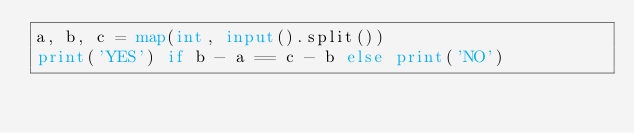<code> <loc_0><loc_0><loc_500><loc_500><_Python_>a, b, c = map(int, input().split())
print('YES') if b - a == c - b else print('NO')</code> 